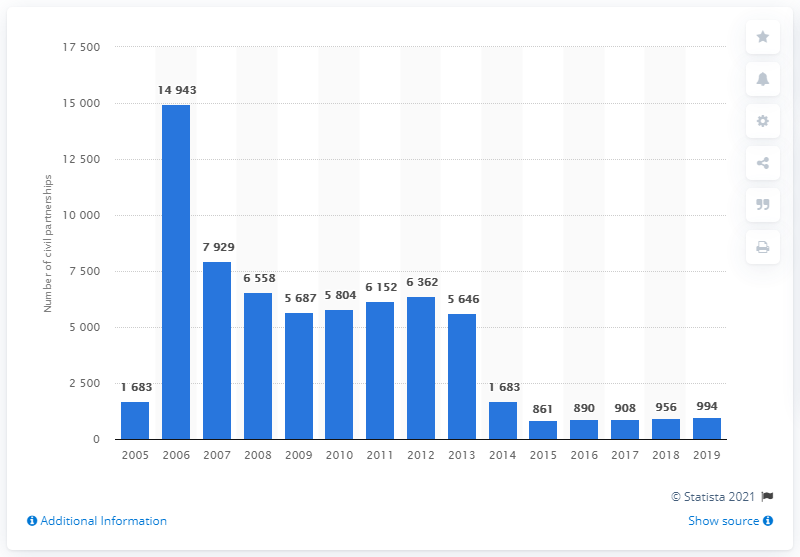Identify some key points in this picture. In 2018, there were 956 civil partnerships in the UK. The first civil partnership was legally recognized in the United Kingdom in 2005. In 2019, the highest number of civil partnerships in the UK was 994. In the year 2013, civil partnerships became legal in the United Kingdom. 